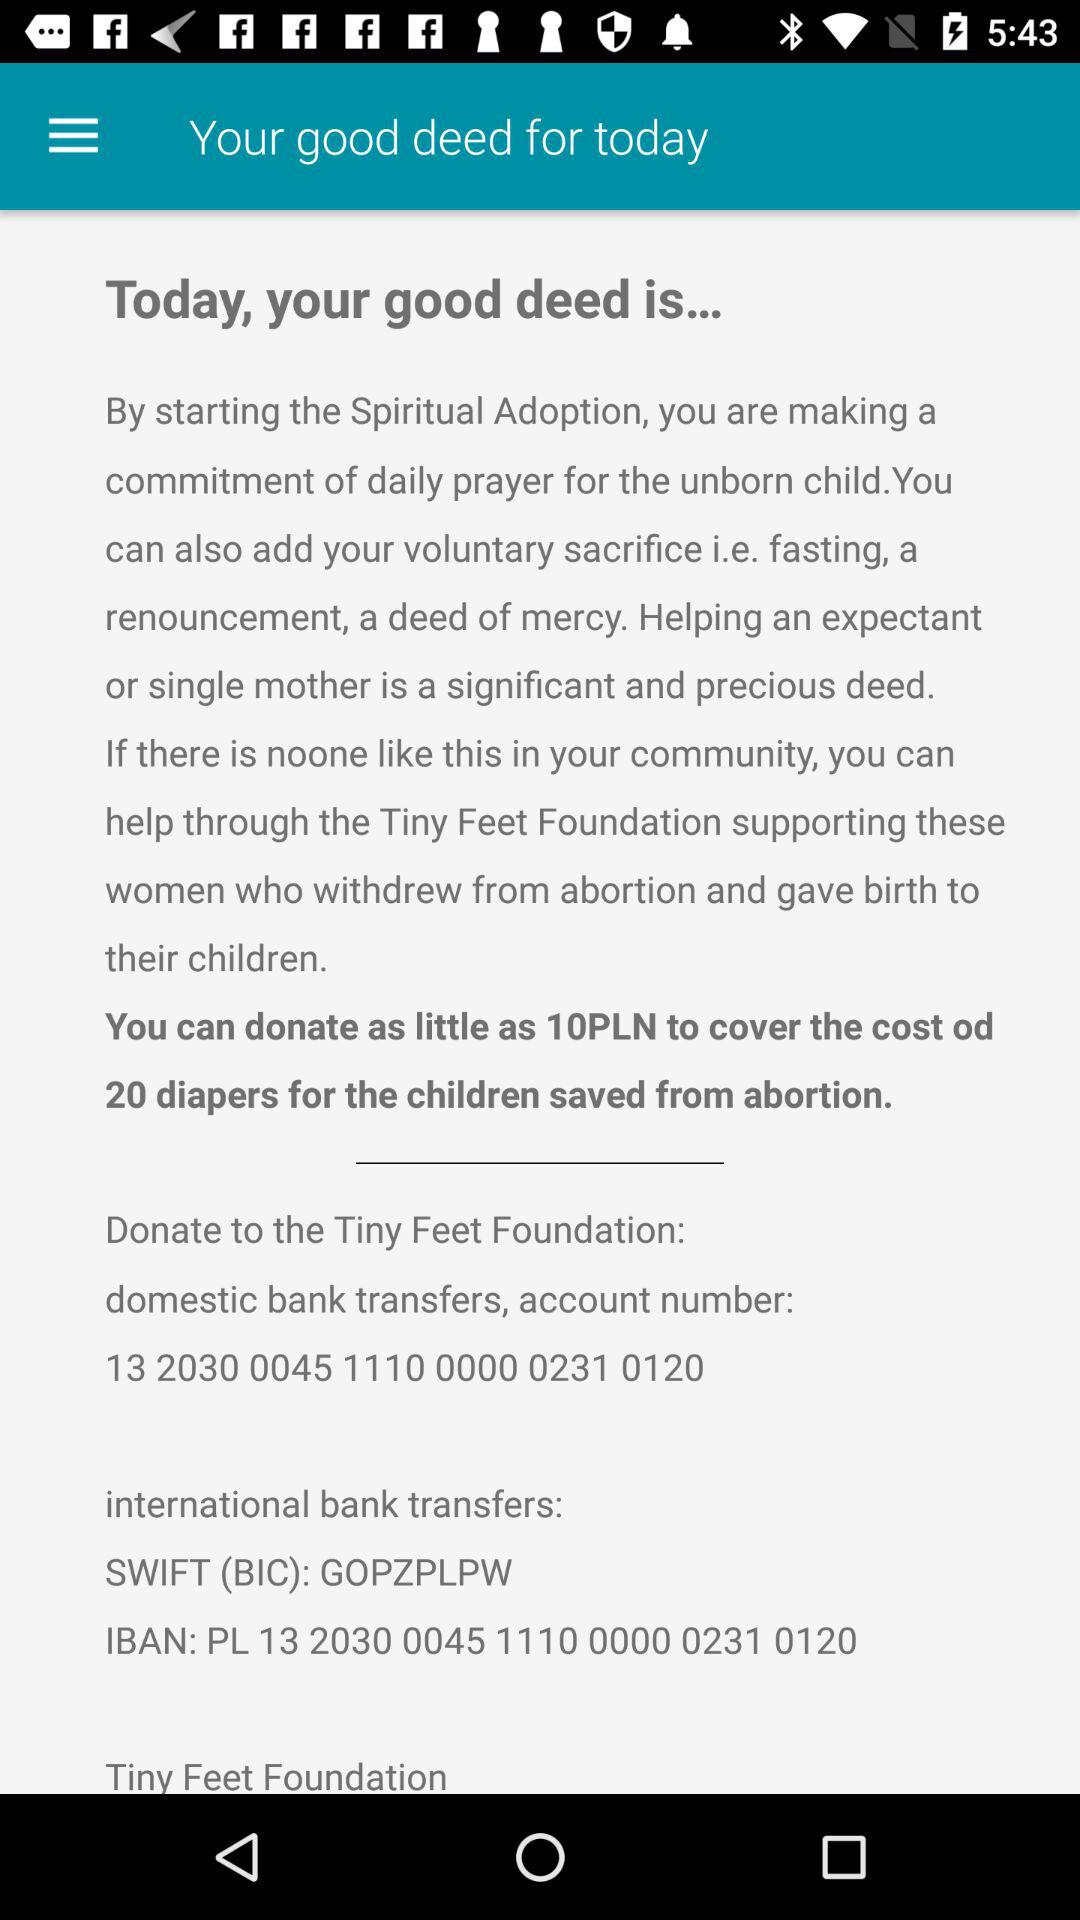What is the IBAN number? The IBAN number is PL 13 2030 0045 1110 0000 0231 0120. 